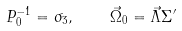<formula> <loc_0><loc_0><loc_500><loc_500>P _ { 0 } ^ { - 1 } = \sigma _ { 3 } , \quad \vec { \Omega } _ { 0 } = \vec { \Lambda } \Sigma { ^ { \prime } }</formula> 